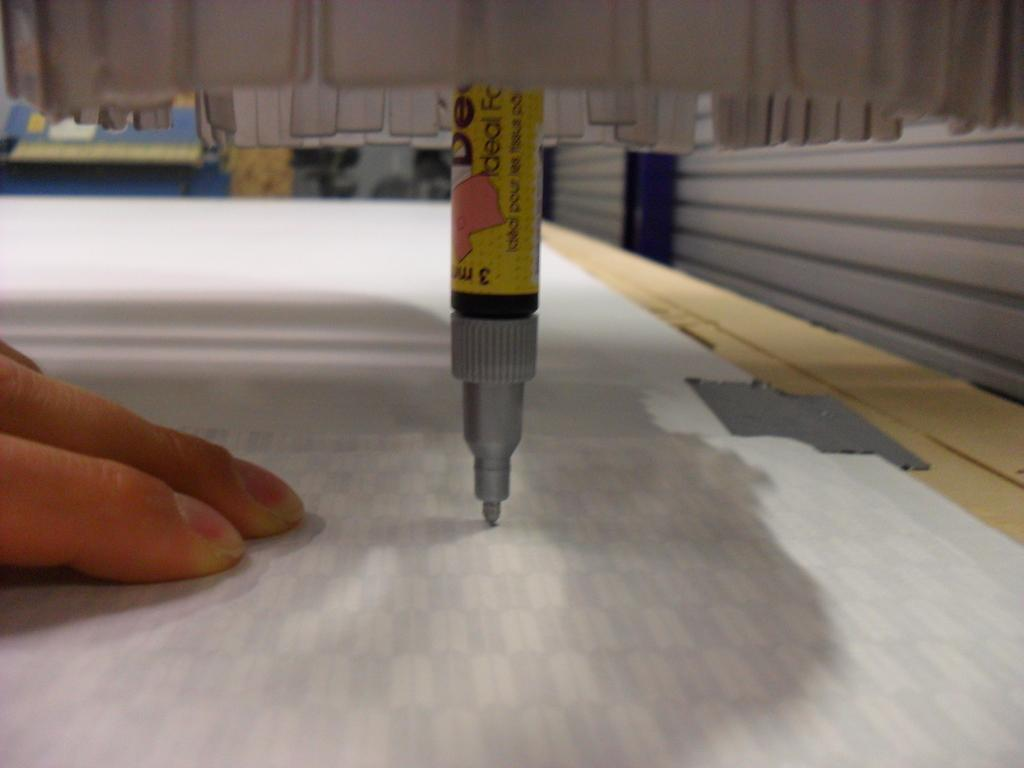<image>
Give a short and clear explanation of the subsequent image. a marker facing directly downward on paper with a label that says 'ideal' on it 